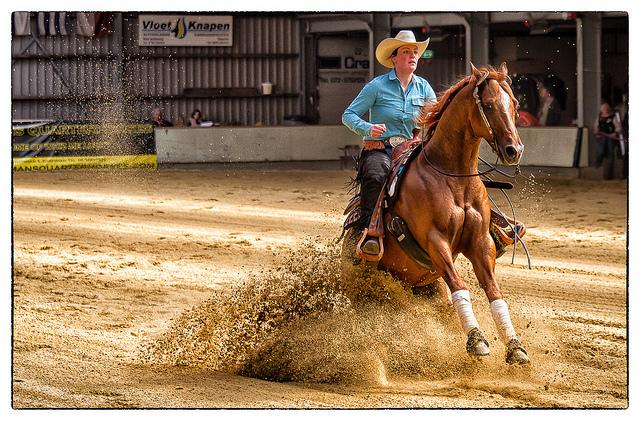Why is the horse on the the ground? stopping 